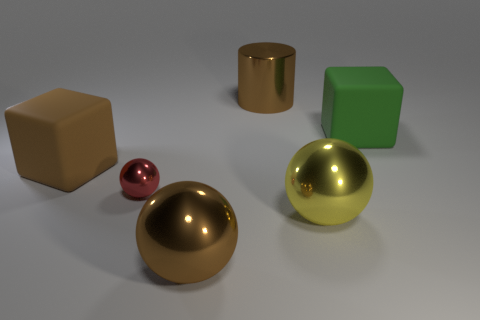There is a sphere that is to the left of the brown ball; does it have the same size as the block that is on the right side of the red metal object?
Your answer should be very brief. No. What number of small red blocks have the same material as the large yellow thing?
Make the answer very short. 0. The tiny metallic ball is what color?
Offer a terse response. Red. There is a red shiny ball; are there any brown shiny spheres left of it?
Your answer should be very brief. No. Is the color of the cylinder the same as the small thing?
Your answer should be very brief. No. How many big spheres are the same color as the tiny ball?
Keep it short and to the point. 0. There is a matte object right of the rubber object that is on the left side of the large brown metal cylinder; what size is it?
Make the answer very short. Large. What shape is the big yellow metal thing?
Provide a succinct answer. Sphere. There is a big brown object that is behind the green cube; what is it made of?
Make the answer very short. Metal. What is the color of the matte block that is left of the brown thing behind the brown cube that is on the left side of the red object?
Offer a terse response. Brown. 